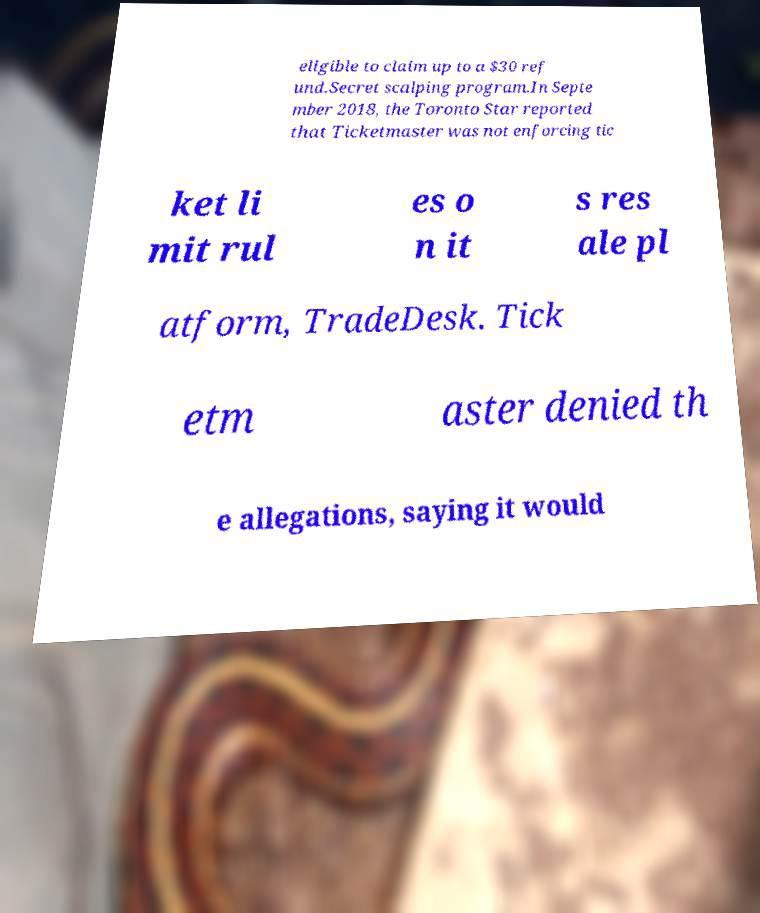Please read and relay the text visible in this image. What does it say? eligible to claim up to a $30 ref und.Secret scalping program.In Septe mber 2018, the Toronto Star reported that Ticketmaster was not enforcing tic ket li mit rul es o n it s res ale pl atform, TradeDesk. Tick etm aster denied th e allegations, saying it would 